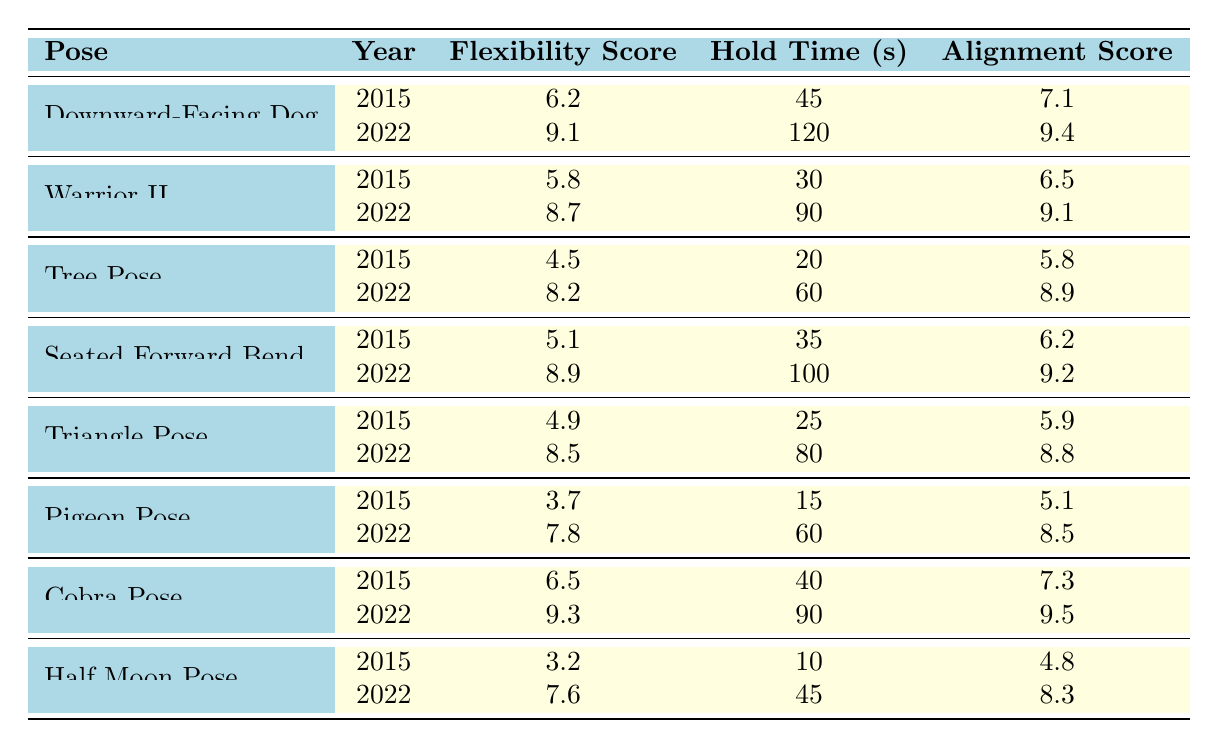What was the flexibility score for Downward-Facing Dog in 2015? The table lists the flexibility score for Downward-Facing Dog in 2015 as 6.2.
Answer: 6.2 How long was the hold time for Tree Pose in 2022? According to the table, the hold time for Tree Pose in 2022 is 60 seconds.
Answer: 60 seconds Which pose had the highest flexibility score in 2022? By comparing the flexibility scores of all poses in 2022, Cobra Pose scored 9.3, which is the highest.
Answer: Cobra Pose What is the difference in alignment scores for Warrior II between 2015 and 2022? The alignment score for Warrior II in 2022 is 9.1 and in 2015 it was 6.5. The difference is 9.1 - 6.5 = 2.6.
Answer: 2.6 Was the flexibility score for Seated Forward Bend in 2022 greater than 8? The score for Seated Forward Bend in 2022 is 8.9, which is greater than 8.
Answer: Yes Calculate the average hold time for Downward-Facing Dog across both years. The hold times for Downward-Facing Dog are 45 seconds in 2015 and 120 seconds in 2022. The average is (45 + 120) / 2 = 82.5 seconds.
Answer: 82.5 seconds Which two poses had the highest flexibility scores in 2015? From the table, the highest flexibility scores in 2015 were for Cobra Pose (6.5) and Downward-Facing Dog (6.2).
Answer: Cobra Pose and Downward-Facing Dog Is the hold time for Half Moon Pose in 2022 shorter than that for Pigeon Pose? The hold time for Half Moon Pose in 2022 is 45 seconds while for Pigeon Pose it is 60 seconds. So, 45 seconds is shorter than 60 seconds.
Answer: Yes What was the overall improvement in flexibility score for the Tree Pose from 2015 to 2022? The flexibility score for Tree Pose improved from 4.5 in 2015 to 8.2 in 2022, leading to an improvement of 8.2 - 4.5 = 3.7.
Answer: 3.7 Calculate the total alignment score for all poses in 2022. The alignment scores for 2022 are 9.4 (Downward-Facing Dog) + 9.1 (Warrior II) + 8.9 (Tree Pose) + 9.2 (Seated Forward Bend) + 8.8 (Triangle Pose) + 8.5 (Pigeon Pose) + 9.5 (Cobra Pose) + 8.3 (Half Moon Pose). The sum is 9.4 + 9.1 + 8.9 + 9.2 + 8.8 + 8.5 + 9.5 + 8.3 = 81.7.
Answer: 81.7 